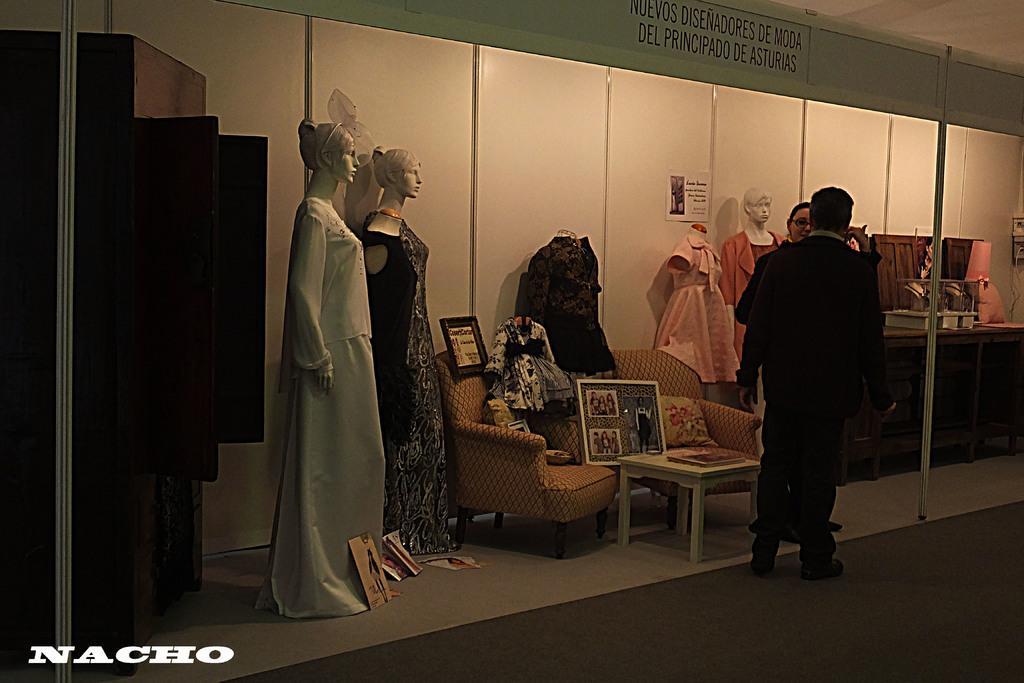Describe this image in one or two sentences. In this there are two persons standing and there are dummies and there are clothes, boards and pillows on the sofa and there are objects on the table. At the back there are objects on the table. There are boards on the wall. On the left side of the image there is a cupboard. At the bottom right there is a text. 